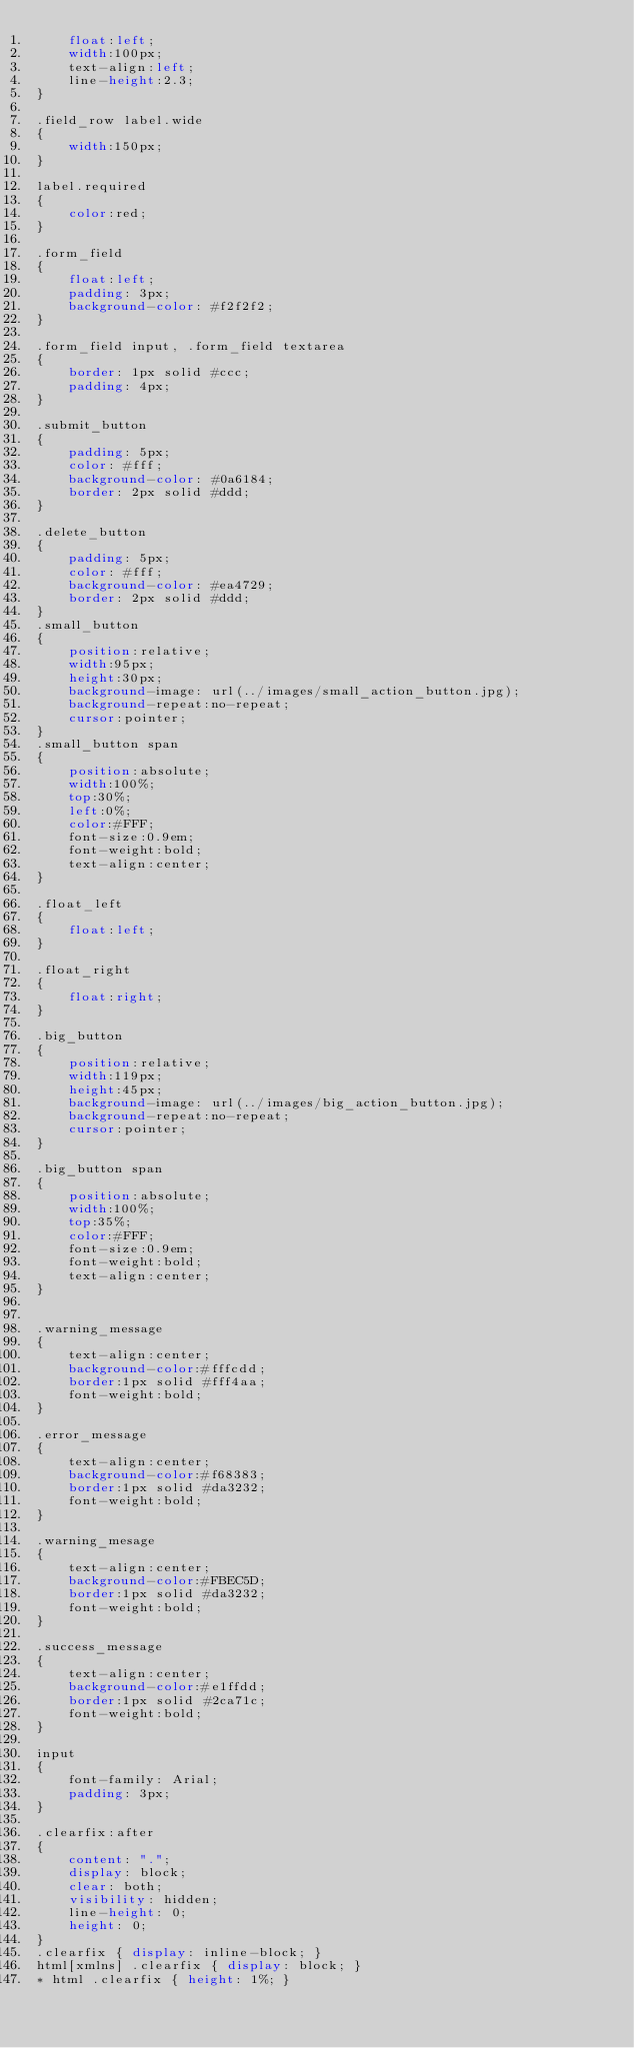<code> <loc_0><loc_0><loc_500><loc_500><_CSS_>	float:left;
	width:100px;
	text-align:left;
	line-height:2.3;
}

.field_row label.wide 
{
 	width:150px;
}

label.required
{
	color:red;
}
 
.form_field
{
 	float:left;
 	padding: 3px;
 	background-color: #f2f2f2;
}
  
.form_field input, .form_field textarea 
{
 	border: 1px solid #ccc;
 	padding: 4px;
}

.submit_button 
{
	padding: 5px;
	color: #fff;
	background-color: #0a6184;
	border: 2px solid #ddd;
}

.delete_button 
{
	padding: 5px;
	color: #fff;
	background-color: #ea4729;
	border: 2px solid #ddd;
}
.small_button
{
	position:relative;
	width:95px;
	height:30px;
	background-image: url(../images/small_action_button.jpg);
	background-repeat:no-repeat;
	cursor:pointer;
}
.small_button span
{
	position:absolute;
	width:100%;
	top:30%;
	left:0%;
	color:#FFF;
	font-size:0.9em;
	font-weight:bold;
	text-align:center;
}

.float_left
{
	float:left;
}

.float_right
{
	float:right;
}

.big_button
{
	position:relative;
	width:119px;
	height:45px;
	background-image: url(../images/big_action_button.jpg);
	background-repeat:no-repeat;
	cursor:pointer;
}

.big_button span
{
	position:absolute;
	width:100%;
	top:35%;
	color:#FFF;
	font-size:0.9em;
	font-weight:bold;
	text-align:center;
}


.warning_message
{
	text-align:center;
	background-color:#fffcdd;
	border:1px solid #fff4aa;
	font-weight:bold;
}

.error_message
{
	text-align:center;
	background-color:#f68383;
	border:1px solid #da3232;
	font-weight:bold;
}

.warning_mesage
{
	text-align:center;
	background-color:#FBEC5D;
	border:1px solid #da3232;
	font-weight:bold;
}

.success_message
{
	text-align:center;
	background-color:#e1ffdd;
	border:1px solid #2ca71c;
	font-weight:bold;
}

input
{
	font-family: Arial;
	padding: 3px;
}

.clearfix:after 
{
	content: ".";
	display: block;
	clear: both;
	visibility: hidden;
	line-height: 0;
	height: 0;
}
.clearfix { display: inline-block; }
html[xmlns] .clearfix {	display: block; }
* html .clearfix { height: 1%; }
</code> 